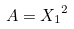Convert formula to latex. <formula><loc_0><loc_0><loc_500><loc_500>A = { X _ { 1 } } ^ { 2 }</formula> 